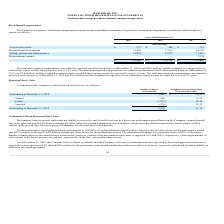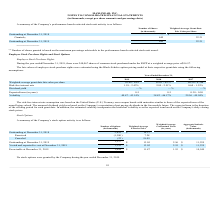According to Maxlinear's financial document, What is the number of shares Outstanding at December 31, 2019? According to the financial document, 445 (in thousands). The relevant text states: "Granted (1) 445 22.21..." Also, What percentage of each performance-based award is subject to the net sales metric for the performance period? According to the financial document, 60%. The relevant text states: "ance-based restricted stock units granted in 2019, 60% of each performance-based award is subject to the net sales metric for the performance period..." Also, What was the number of shares granted in 2019? According to the financial document, 445 (in thousands). The relevant text states: "Granted (1) 445 22.21..." Also, can you calculate: What was the change in the outstanding from 2018 to 2019? Based on the calculation: 445 - 0 , the result is 445 (in thousands). This is based on the information: "Outstanding at December 31, 2019 445 22.21 Outstanding at December 31, 2019 445 22.21..." The key data points involved are: 0. Also, can you calculate: What percentage of outstanding in 2019 was granted shares? Based on the calculation: 445 / 445, the result is 100 (percentage). This is based on the information: "Granted (1) 445 22.21..." Additionally, In which year was outstanding shares less than 200 thousands? According to the financial document, 2018. The relevant text states: "2019 2018 2017..." 